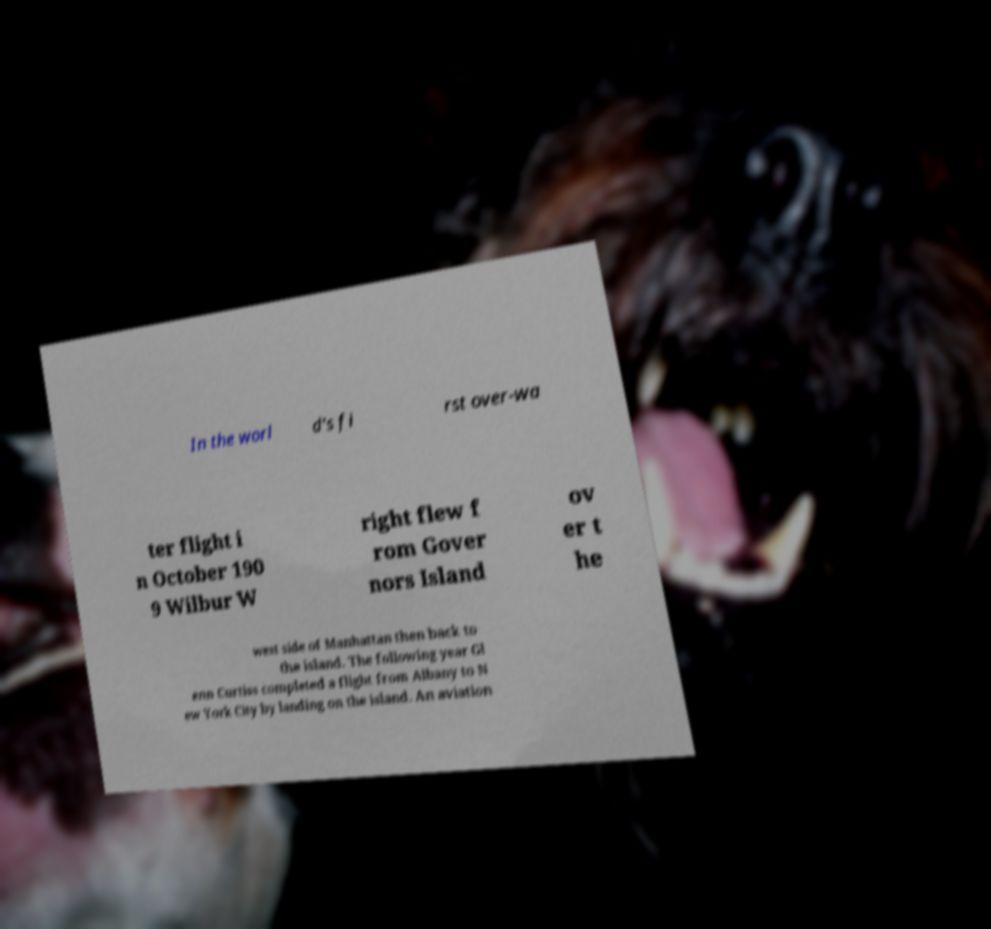Please read and relay the text visible in this image. What does it say? In the worl d's fi rst over-wa ter flight i n October 190 9 Wilbur W right flew f rom Gover nors Island ov er t he west side of Manhattan then back to the island. The following year Gl enn Curtiss completed a flight from Albany to N ew York City by landing on the island. An aviation 